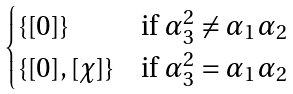<formula> <loc_0><loc_0><loc_500><loc_500>\begin{cases} \{ [ 0 ] \} & \text {if $\alpha_{3}^{2} \neq \alpha_{1} \alpha_{2}$} \\ \{ [ 0 ] , [ \chi ] \} & \text {if $\alpha_{3}^{2} = \alpha_{1} \alpha_{2}$} \end{cases}</formula> 